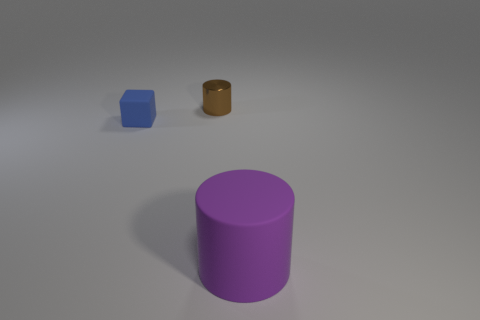The thing that is made of the same material as the large cylinder is what color?
Provide a short and direct response. Blue. Are there fewer small blue blocks behind the small metal cylinder than small cylinders?
Your answer should be very brief. Yes. What is the shape of the big object that is the same material as the blue cube?
Ensure brevity in your answer.  Cylinder. How many matte things are either large purple cubes or large purple things?
Keep it short and to the point. 1. Are there the same number of purple matte things left of the purple cylinder and purple rubber objects?
Give a very brief answer. No. Is the color of the cylinder that is behind the matte cylinder the same as the large thing?
Keep it short and to the point. No. What is the material of the thing that is in front of the small cylinder and behind the large rubber thing?
Keep it short and to the point. Rubber. There is a small thing that is in front of the small brown thing; are there any small blue things that are behind it?
Your answer should be very brief. No. Are the big thing and the small brown thing made of the same material?
Offer a very short reply. No. There is a thing that is behind the big purple thing and in front of the tiny brown metal object; what shape is it?
Offer a terse response. Cube. 